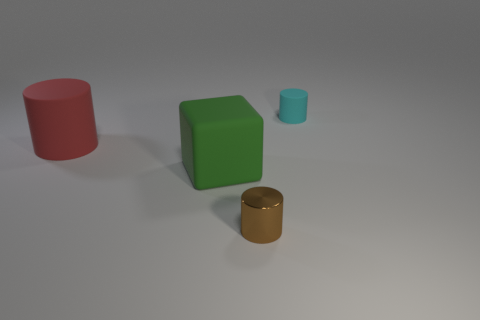Are there any objects of the same color as the large cylinder?
Keep it short and to the point. No. How many small gray matte cubes are there?
Your answer should be very brief. 0. What material is the tiny thing behind the rubber cylinder in front of the rubber cylinder that is behind the red matte thing made of?
Offer a very short reply. Rubber. Are there any gray balls that have the same material as the large red thing?
Your answer should be very brief. No. Do the big green cube and the cyan thing have the same material?
Keep it short and to the point. Yes. What number of cylinders are rubber objects or tiny cyan objects?
Make the answer very short. 2. What is the color of the large cylinder that is the same material as the large green cube?
Provide a succinct answer. Red. Is the number of cubes less than the number of tiny objects?
Keep it short and to the point. Yes. Is the shape of the object that is right of the metallic cylinder the same as the rubber object that is in front of the large red rubber thing?
Offer a terse response. No. How many objects are either metallic spheres or brown objects?
Your answer should be compact. 1. 